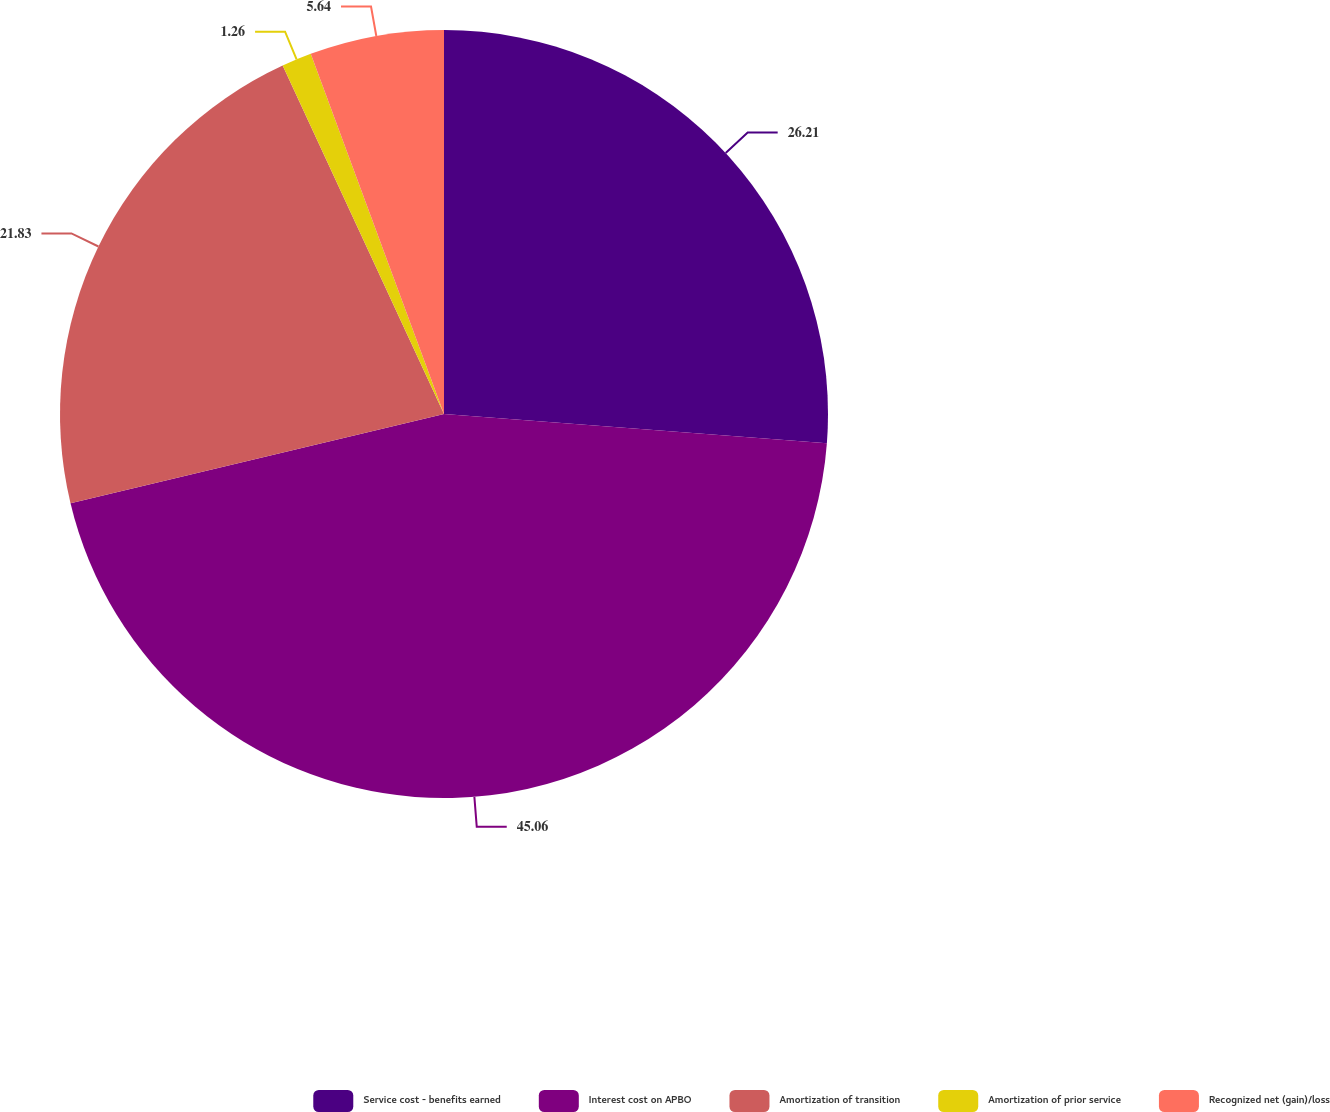Convert chart to OTSL. <chart><loc_0><loc_0><loc_500><loc_500><pie_chart><fcel>Service cost - benefits earned<fcel>Interest cost on APBO<fcel>Amortization of transition<fcel>Amortization of prior service<fcel>Recognized net (gain)/loss<nl><fcel>26.21%<fcel>45.05%<fcel>21.83%<fcel>1.26%<fcel>5.64%<nl></chart> 